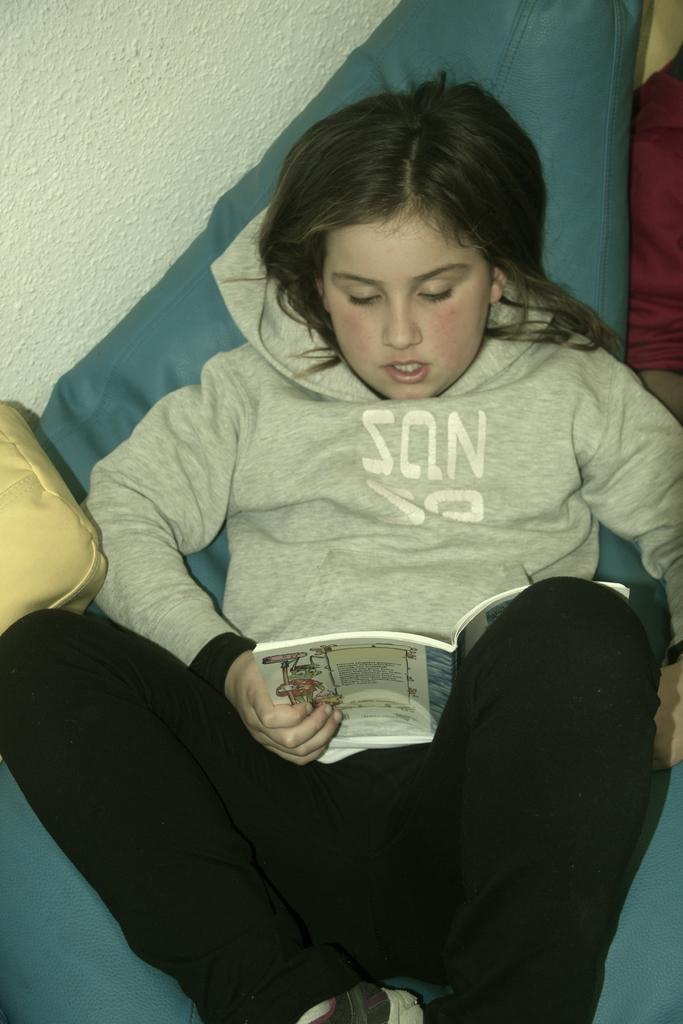Describe this image in one or two sentences. In this image I can see a girl , laying on sofa set , in the top left I can see the wall. 